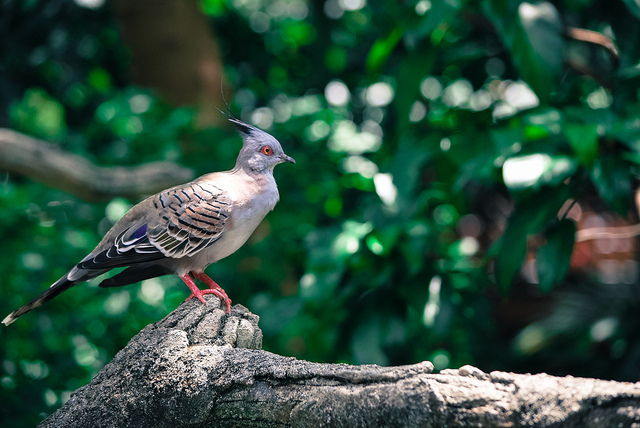<image>What type of bird is in the image? It is unclear what type of bird is in the image. It could be a hummingbird, pigeon, finch, sparrow, robin, or blue jay. What type of bird is in the image? I don't know what type of bird is in the image. It can be humming, pigeon, finch, gray, hummingbird, sparrow, robin, or blue jay. 